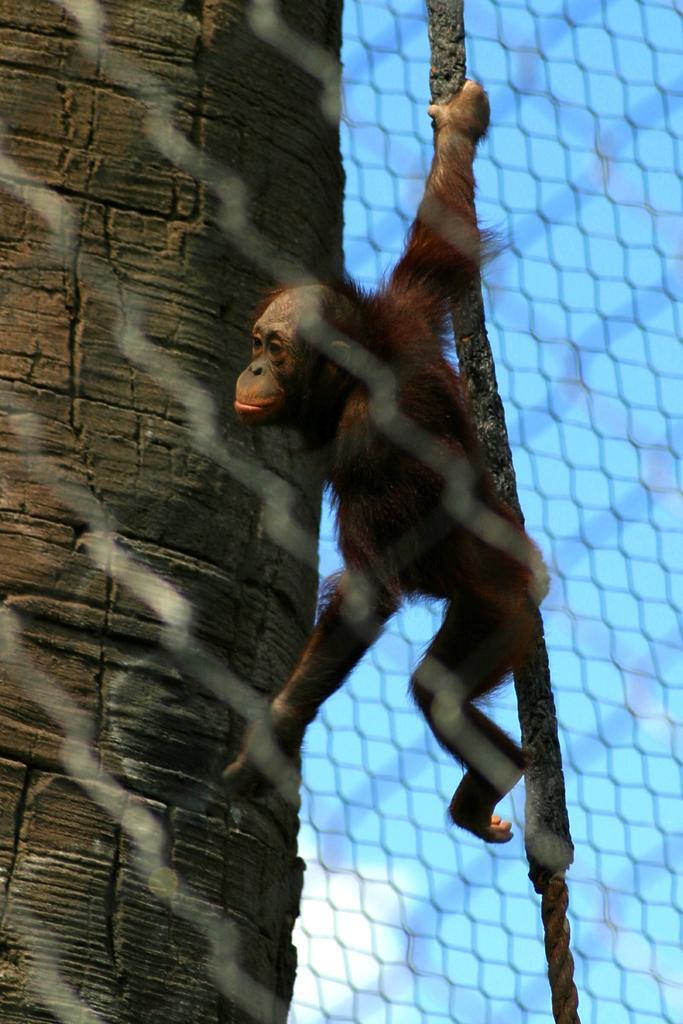Could you give a brief overview of what you see in this image? In this picture we can see fence and an animal. 